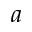Convert formula to latex. <formula><loc_0><loc_0><loc_500><loc_500>a</formula> 